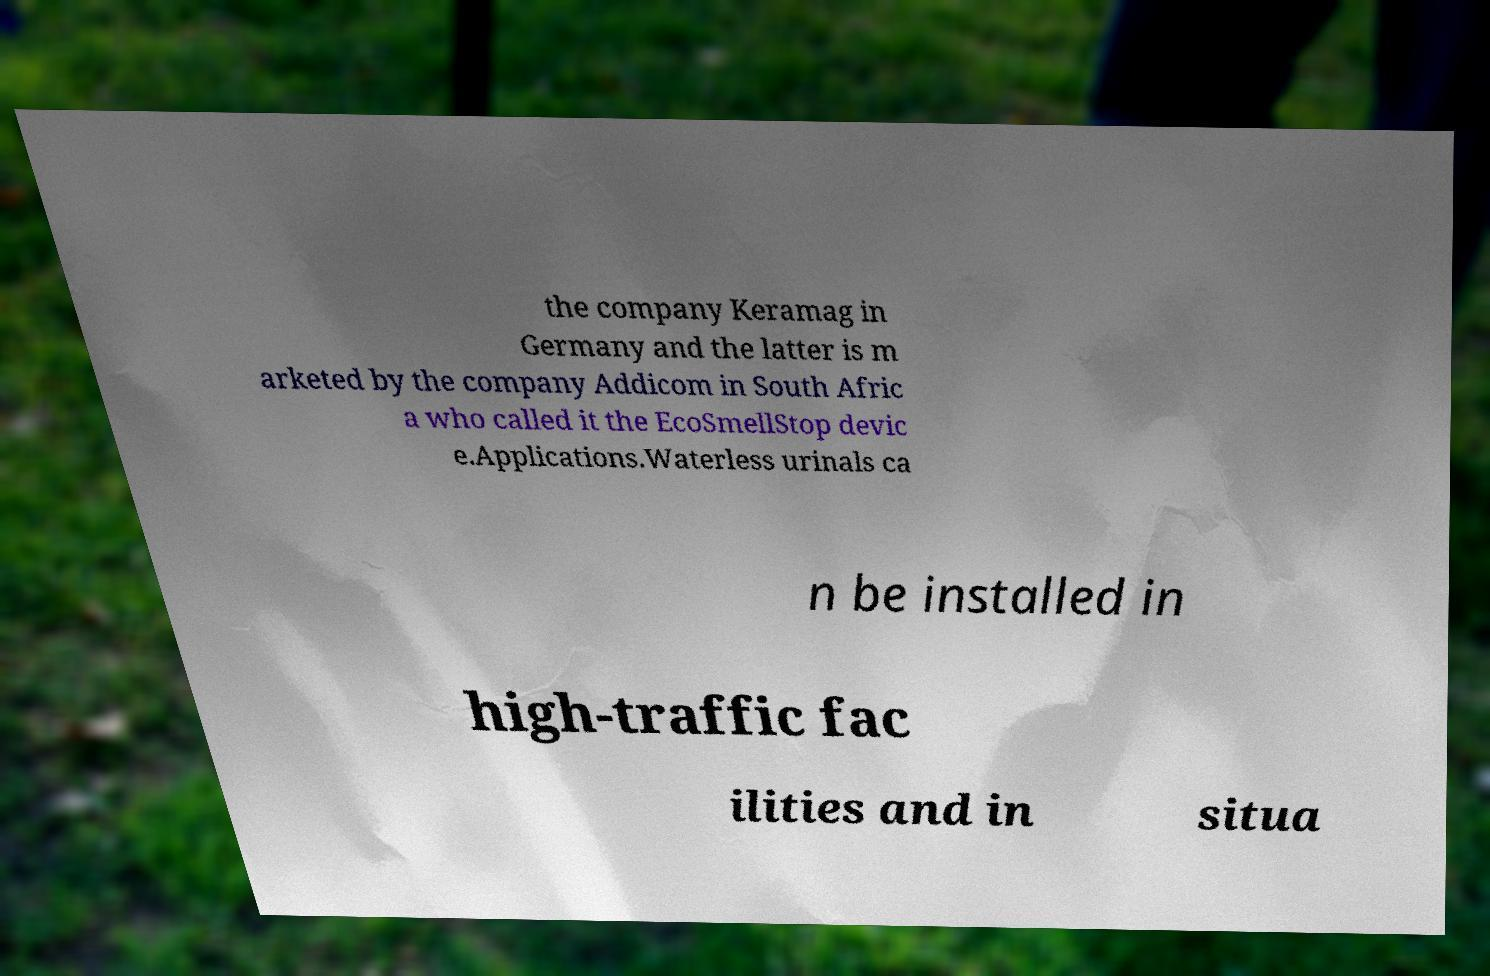There's text embedded in this image that I need extracted. Can you transcribe it verbatim? the company Keramag in Germany and the latter is m arketed by the company Addicom in South Afric a who called it the EcoSmellStop devic e.Applications.Waterless urinals ca n be installed in high-traffic fac ilities and in situa 